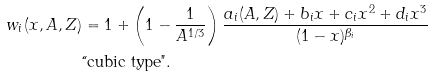<formula> <loc_0><loc_0><loc_500><loc_500>w _ { i } ( x , A , Z ) & = 1 + \left ( 1 - \frac { 1 } { A ^ { 1 / 3 } } \right ) \frac { a _ { i } ( A , Z ) + b _ { i } x + c _ { i } x ^ { 2 } + d _ { i } x ^ { 3 } } { ( 1 - x ) ^ { \beta _ { i } } } \\ & \text {``cubic type"} .</formula> 